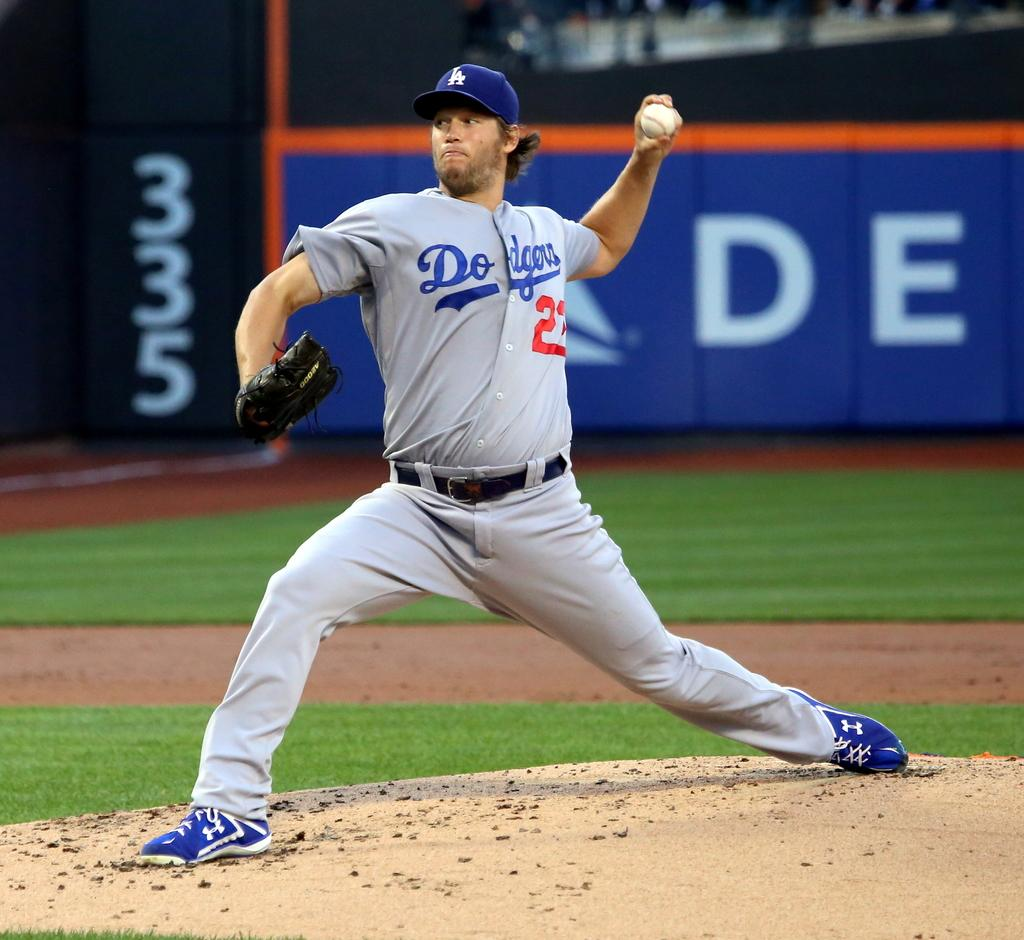<image>
Summarize the visual content of the image. The Dodgers pitcher, number 22 is in the process of throwing the ball. 